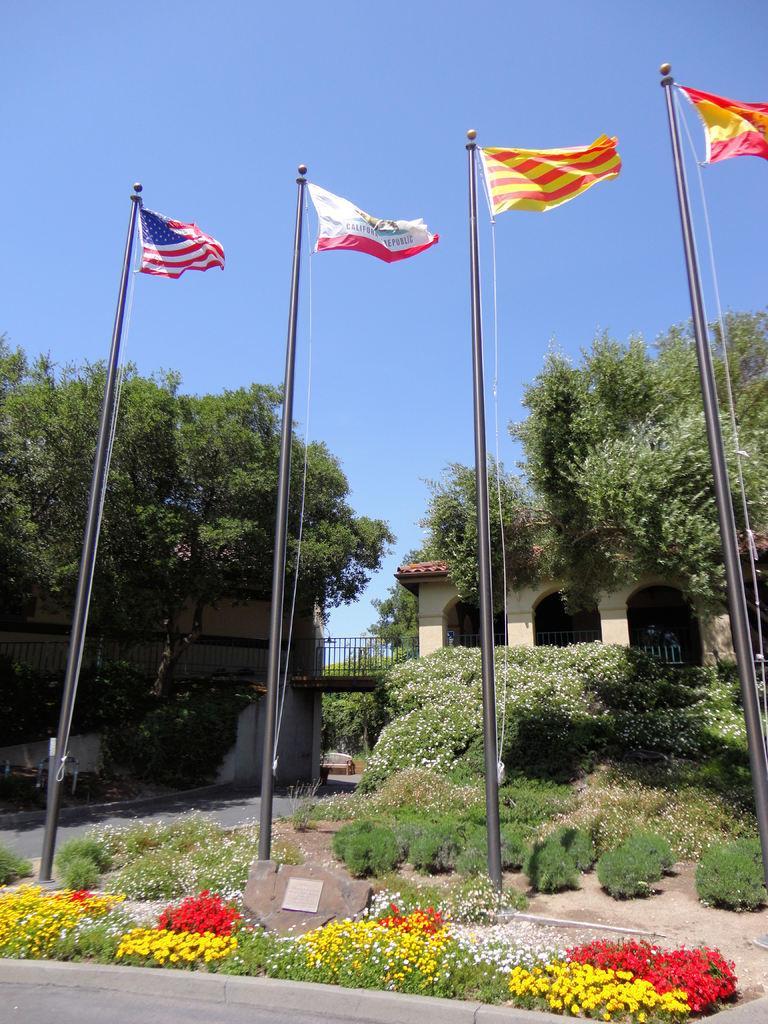Could you give a brief overview of what you see in this image? In the foreground of the image we can see group of flowers , ropes on poles , a memorial placed on the ground and group of flowers on plants. In the center of the image we can see buildings with bridge , railing and arches. In the background, we can see some trees and the sky. 